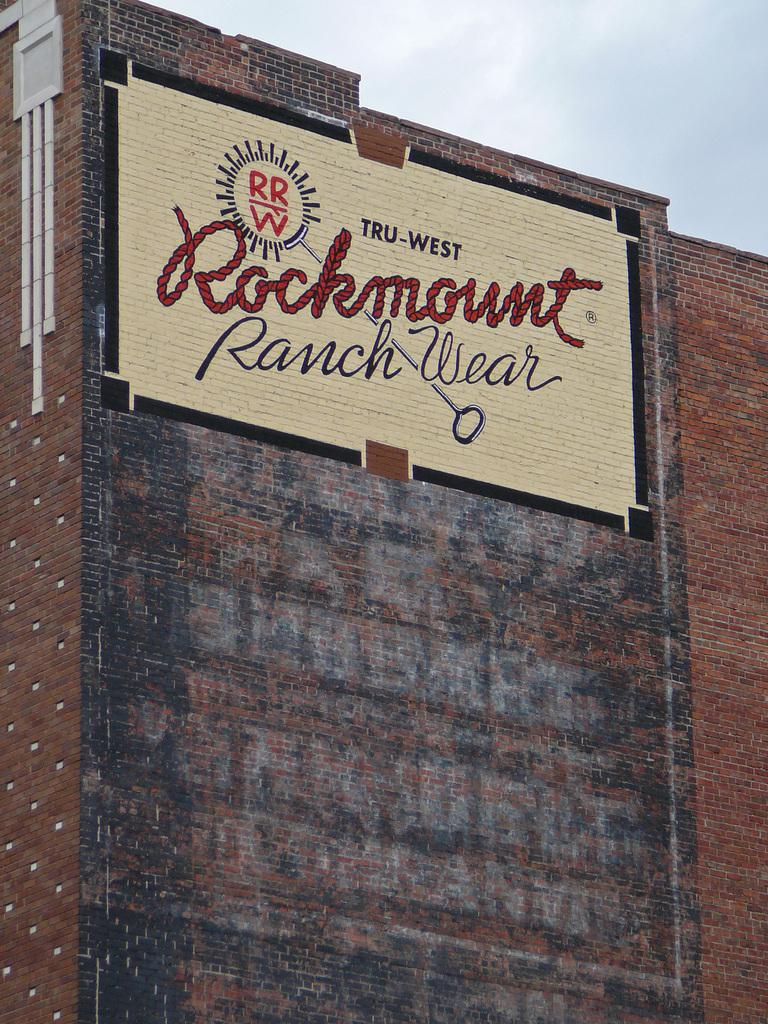What is the main subject of the image? There is a painting in the image. Where is the painting located? The painting is on a brick wall. What can be seen in the background of the image? There are clouds visible in the background of the image. What type of vest is the girl wearing in the image? There is no girl or vest present in the image; it only features a painting on a brick wall with clouds in the background. 